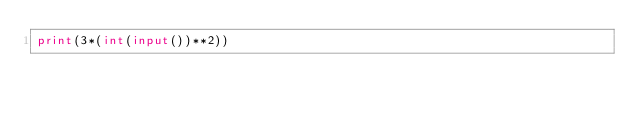<code> <loc_0><loc_0><loc_500><loc_500><_Python_>print(3*(int(input())**2))</code> 